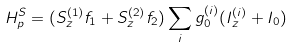Convert formula to latex. <formula><loc_0><loc_0><loc_500><loc_500>H _ { p } ^ { S } = ( S _ { z } ^ { ( 1 ) } f _ { 1 } + S _ { z } ^ { ( 2 ) } f _ { 2 } ) \sum _ { i } g _ { 0 } ^ { ( i ) } ( I _ { z } ^ { ( i ) } + I _ { 0 } )</formula> 